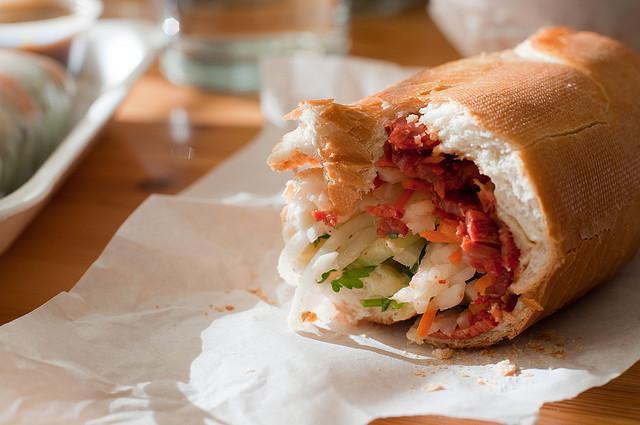Does the caption "The sandwich is at the edge of the dining table." correctly depict the image?
Answer yes or no. No. 